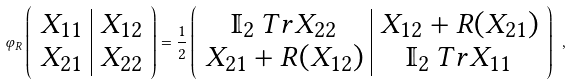Convert formula to latex. <formula><loc_0><loc_0><loc_500><loc_500>\varphi _ { R } \left ( \begin{array} { c | c } X _ { 1 1 } & X _ { 1 2 } \\ X _ { 2 1 } & X _ { 2 2 } \end{array} \right ) = \frac { 1 } { 2 } \left ( \begin{array} { c | c } \mathbb { I } _ { 2 } \, T r X _ { 2 2 } & X _ { 1 2 } + R ( X _ { 2 1 } ) \\ X _ { 2 1 } + R ( X _ { 1 2 } ) & \mathbb { I } _ { 2 } \, T r X _ { 1 1 } \end{array} \right ) \ ,</formula> 